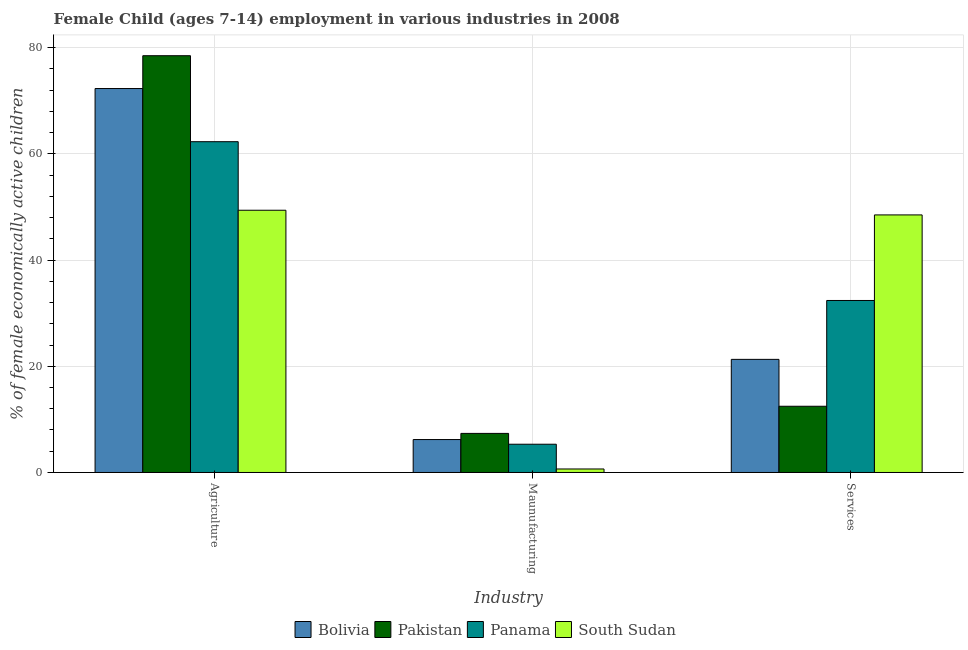How many different coloured bars are there?
Your answer should be very brief. 4. Are the number of bars per tick equal to the number of legend labels?
Ensure brevity in your answer.  Yes. Are the number of bars on each tick of the X-axis equal?
Ensure brevity in your answer.  Yes. What is the label of the 3rd group of bars from the left?
Offer a very short reply. Services. What is the percentage of economically active children in services in Pakistan?
Your answer should be very brief. 12.47. Across all countries, what is the maximum percentage of economically active children in services?
Provide a short and direct response. 48.5. Across all countries, what is the minimum percentage of economically active children in services?
Your answer should be very brief. 12.47. In which country was the percentage of economically active children in services maximum?
Make the answer very short. South Sudan. In which country was the percentage of economically active children in agriculture minimum?
Offer a very short reply. South Sudan. What is the total percentage of economically active children in services in the graph?
Give a very brief answer. 114.66. What is the difference between the percentage of economically active children in manufacturing in Panama and that in Bolivia?
Offer a terse response. -0.88. What is the difference between the percentage of economically active children in services in Panama and the percentage of economically active children in agriculture in Pakistan?
Provide a succinct answer. -46.09. What is the average percentage of economically active children in services per country?
Provide a succinct answer. 28.66. What is the difference between the percentage of economically active children in services and percentage of economically active children in manufacturing in Panama?
Provide a succinct answer. 27.07. What is the ratio of the percentage of economically active children in manufacturing in South Sudan to that in Pakistan?
Keep it short and to the point. 0.09. Is the percentage of economically active children in manufacturing in Bolivia less than that in South Sudan?
Keep it short and to the point. No. Is the difference between the percentage of economically active children in services in Panama and South Sudan greater than the difference between the percentage of economically active children in manufacturing in Panama and South Sudan?
Make the answer very short. No. What is the difference between the highest and the second highest percentage of economically active children in services?
Ensure brevity in your answer.  16.11. What is the difference between the highest and the lowest percentage of economically active children in agriculture?
Provide a succinct answer. 29.1. What does the 4th bar from the left in Services represents?
Offer a very short reply. South Sudan. What does the 1st bar from the right in Maunufacturing represents?
Your answer should be compact. South Sudan. Is it the case that in every country, the sum of the percentage of economically active children in agriculture and percentage of economically active children in manufacturing is greater than the percentage of economically active children in services?
Your answer should be compact. Yes. How many bars are there?
Make the answer very short. 12. Are all the bars in the graph horizontal?
Offer a terse response. No. How many countries are there in the graph?
Your answer should be compact. 4. What is the difference between two consecutive major ticks on the Y-axis?
Your response must be concise. 20. How many legend labels are there?
Your answer should be compact. 4. What is the title of the graph?
Give a very brief answer. Female Child (ages 7-14) employment in various industries in 2008. What is the label or title of the X-axis?
Offer a very short reply. Industry. What is the label or title of the Y-axis?
Offer a terse response. % of female economically active children. What is the % of female economically active children in Bolivia in Agriculture?
Keep it short and to the point. 72.3. What is the % of female economically active children of Pakistan in Agriculture?
Offer a terse response. 78.48. What is the % of female economically active children in Panama in Agriculture?
Offer a very short reply. 62.29. What is the % of female economically active children of South Sudan in Agriculture?
Keep it short and to the point. 49.38. What is the % of female economically active children of Pakistan in Maunufacturing?
Give a very brief answer. 7.36. What is the % of female economically active children in Panama in Maunufacturing?
Offer a very short reply. 5.32. What is the % of female economically active children of South Sudan in Maunufacturing?
Ensure brevity in your answer.  0.66. What is the % of female economically active children of Bolivia in Services?
Provide a succinct answer. 21.3. What is the % of female economically active children in Pakistan in Services?
Provide a short and direct response. 12.47. What is the % of female economically active children in Panama in Services?
Give a very brief answer. 32.39. What is the % of female economically active children of South Sudan in Services?
Your answer should be very brief. 48.5. Across all Industry, what is the maximum % of female economically active children in Bolivia?
Provide a succinct answer. 72.3. Across all Industry, what is the maximum % of female economically active children in Pakistan?
Give a very brief answer. 78.48. Across all Industry, what is the maximum % of female economically active children in Panama?
Ensure brevity in your answer.  62.29. Across all Industry, what is the maximum % of female economically active children of South Sudan?
Provide a short and direct response. 49.38. Across all Industry, what is the minimum % of female economically active children of Bolivia?
Give a very brief answer. 6.2. Across all Industry, what is the minimum % of female economically active children in Pakistan?
Your answer should be very brief. 7.36. Across all Industry, what is the minimum % of female economically active children in Panama?
Keep it short and to the point. 5.32. Across all Industry, what is the minimum % of female economically active children of South Sudan?
Ensure brevity in your answer.  0.66. What is the total % of female economically active children of Bolivia in the graph?
Provide a succinct answer. 99.8. What is the total % of female economically active children in Pakistan in the graph?
Keep it short and to the point. 98.31. What is the total % of female economically active children in South Sudan in the graph?
Give a very brief answer. 98.54. What is the difference between the % of female economically active children in Bolivia in Agriculture and that in Maunufacturing?
Give a very brief answer. 66.1. What is the difference between the % of female economically active children of Pakistan in Agriculture and that in Maunufacturing?
Keep it short and to the point. 71.12. What is the difference between the % of female economically active children in Panama in Agriculture and that in Maunufacturing?
Provide a short and direct response. 56.97. What is the difference between the % of female economically active children in South Sudan in Agriculture and that in Maunufacturing?
Your answer should be very brief. 48.72. What is the difference between the % of female economically active children in Pakistan in Agriculture and that in Services?
Your answer should be very brief. 66.01. What is the difference between the % of female economically active children of Panama in Agriculture and that in Services?
Offer a very short reply. 29.9. What is the difference between the % of female economically active children in Bolivia in Maunufacturing and that in Services?
Give a very brief answer. -15.1. What is the difference between the % of female economically active children in Pakistan in Maunufacturing and that in Services?
Make the answer very short. -5.11. What is the difference between the % of female economically active children in Panama in Maunufacturing and that in Services?
Give a very brief answer. -27.07. What is the difference between the % of female economically active children of South Sudan in Maunufacturing and that in Services?
Your response must be concise. -47.84. What is the difference between the % of female economically active children of Bolivia in Agriculture and the % of female economically active children of Pakistan in Maunufacturing?
Give a very brief answer. 64.94. What is the difference between the % of female economically active children of Bolivia in Agriculture and the % of female economically active children of Panama in Maunufacturing?
Your response must be concise. 66.98. What is the difference between the % of female economically active children in Bolivia in Agriculture and the % of female economically active children in South Sudan in Maunufacturing?
Provide a short and direct response. 71.64. What is the difference between the % of female economically active children of Pakistan in Agriculture and the % of female economically active children of Panama in Maunufacturing?
Your answer should be compact. 73.16. What is the difference between the % of female economically active children of Pakistan in Agriculture and the % of female economically active children of South Sudan in Maunufacturing?
Your answer should be very brief. 77.82. What is the difference between the % of female economically active children in Panama in Agriculture and the % of female economically active children in South Sudan in Maunufacturing?
Your answer should be compact. 61.63. What is the difference between the % of female economically active children in Bolivia in Agriculture and the % of female economically active children in Pakistan in Services?
Your answer should be compact. 59.83. What is the difference between the % of female economically active children in Bolivia in Agriculture and the % of female economically active children in Panama in Services?
Your answer should be compact. 39.91. What is the difference between the % of female economically active children in Bolivia in Agriculture and the % of female economically active children in South Sudan in Services?
Keep it short and to the point. 23.8. What is the difference between the % of female economically active children in Pakistan in Agriculture and the % of female economically active children in Panama in Services?
Give a very brief answer. 46.09. What is the difference between the % of female economically active children of Pakistan in Agriculture and the % of female economically active children of South Sudan in Services?
Provide a succinct answer. 29.98. What is the difference between the % of female economically active children in Panama in Agriculture and the % of female economically active children in South Sudan in Services?
Offer a terse response. 13.79. What is the difference between the % of female economically active children of Bolivia in Maunufacturing and the % of female economically active children of Pakistan in Services?
Your response must be concise. -6.27. What is the difference between the % of female economically active children of Bolivia in Maunufacturing and the % of female economically active children of Panama in Services?
Your answer should be very brief. -26.19. What is the difference between the % of female economically active children of Bolivia in Maunufacturing and the % of female economically active children of South Sudan in Services?
Keep it short and to the point. -42.3. What is the difference between the % of female economically active children of Pakistan in Maunufacturing and the % of female economically active children of Panama in Services?
Offer a terse response. -25.03. What is the difference between the % of female economically active children of Pakistan in Maunufacturing and the % of female economically active children of South Sudan in Services?
Keep it short and to the point. -41.14. What is the difference between the % of female economically active children in Panama in Maunufacturing and the % of female economically active children in South Sudan in Services?
Provide a succinct answer. -43.18. What is the average % of female economically active children of Bolivia per Industry?
Your answer should be compact. 33.27. What is the average % of female economically active children in Pakistan per Industry?
Provide a succinct answer. 32.77. What is the average % of female economically active children of Panama per Industry?
Offer a very short reply. 33.33. What is the average % of female economically active children in South Sudan per Industry?
Your response must be concise. 32.85. What is the difference between the % of female economically active children of Bolivia and % of female economically active children of Pakistan in Agriculture?
Make the answer very short. -6.18. What is the difference between the % of female economically active children in Bolivia and % of female economically active children in Panama in Agriculture?
Provide a succinct answer. 10.01. What is the difference between the % of female economically active children in Bolivia and % of female economically active children in South Sudan in Agriculture?
Offer a very short reply. 22.92. What is the difference between the % of female economically active children of Pakistan and % of female economically active children of Panama in Agriculture?
Your answer should be very brief. 16.19. What is the difference between the % of female economically active children in Pakistan and % of female economically active children in South Sudan in Agriculture?
Give a very brief answer. 29.1. What is the difference between the % of female economically active children of Panama and % of female economically active children of South Sudan in Agriculture?
Your answer should be very brief. 12.91. What is the difference between the % of female economically active children in Bolivia and % of female economically active children in Pakistan in Maunufacturing?
Give a very brief answer. -1.16. What is the difference between the % of female economically active children of Bolivia and % of female economically active children of Panama in Maunufacturing?
Keep it short and to the point. 0.88. What is the difference between the % of female economically active children in Bolivia and % of female economically active children in South Sudan in Maunufacturing?
Make the answer very short. 5.54. What is the difference between the % of female economically active children of Pakistan and % of female economically active children of Panama in Maunufacturing?
Offer a very short reply. 2.04. What is the difference between the % of female economically active children in Pakistan and % of female economically active children in South Sudan in Maunufacturing?
Keep it short and to the point. 6.7. What is the difference between the % of female economically active children of Panama and % of female economically active children of South Sudan in Maunufacturing?
Offer a very short reply. 4.66. What is the difference between the % of female economically active children in Bolivia and % of female economically active children in Pakistan in Services?
Offer a terse response. 8.83. What is the difference between the % of female economically active children of Bolivia and % of female economically active children of Panama in Services?
Provide a short and direct response. -11.09. What is the difference between the % of female economically active children in Bolivia and % of female economically active children in South Sudan in Services?
Your response must be concise. -27.2. What is the difference between the % of female economically active children in Pakistan and % of female economically active children in Panama in Services?
Your response must be concise. -19.92. What is the difference between the % of female economically active children of Pakistan and % of female economically active children of South Sudan in Services?
Offer a terse response. -36.03. What is the difference between the % of female economically active children of Panama and % of female economically active children of South Sudan in Services?
Your answer should be compact. -16.11. What is the ratio of the % of female economically active children of Bolivia in Agriculture to that in Maunufacturing?
Your response must be concise. 11.66. What is the ratio of the % of female economically active children of Pakistan in Agriculture to that in Maunufacturing?
Your response must be concise. 10.66. What is the ratio of the % of female economically active children in Panama in Agriculture to that in Maunufacturing?
Provide a succinct answer. 11.71. What is the ratio of the % of female economically active children in South Sudan in Agriculture to that in Maunufacturing?
Offer a very short reply. 74.82. What is the ratio of the % of female economically active children of Bolivia in Agriculture to that in Services?
Ensure brevity in your answer.  3.39. What is the ratio of the % of female economically active children in Pakistan in Agriculture to that in Services?
Provide a short and direct response. 6.29. What is the ratio of the % of female economically active children of Panama in Agriculture to that in Services?
Your answer should be compact. 1.92. What is the ratio of the % of female economically active children in South Sudan in Agriculture to that in Services?
Ensure brevity in your answer.  1.02. What is the ratio of the % of female economically active children in Bolivia in Maunufacturing to that in Services?
Ensure brevity in your answer.  0.29. What is the ratio of the % of female economically active children in Pakistan in Maunufacturing to that in Services?
Your answer should be very brief. 0.59. What is the ratio of the % of female economically active children in Panama in Maunufacturing to that in Services?
Offer a terse response. 0.16. What is the ratio of the % of female economically active children in South Sudan in Maunufacturing to that in Services?
Ensure brevity in your answer.  0.01. What is the difference between the highest and the second highest % of female economically active children in Bolivia?
Offer a terse response. 51. What is the difference between the highest and the second highest % of female economically active children of Pakistan?
Your response must be concise. 66.01. What is the difference between the highest and the second highest % of female economically active children of Panama?
Your answer should be very brief. 29.9. What is the difference between the highest and the second highest % of female economically active children of South Sudan?
Offer a very short reply. 0.88. What is the difference between the highest and the lowest % of female economically active children in Bolivia?
Your answer should be compact. 66.1. What is the difference between the highest and the lowest % of female economically active children in Pakistan?
Keep it short and to the point. 71.12. What is the difference between the highest and the lowest % of female economically active children in Panama?
Keep it short and to the point. 56.97. What is the difference between the highest and the lowest % of female economically active children of South Sudan?
Your response must be concise. 48.72. 